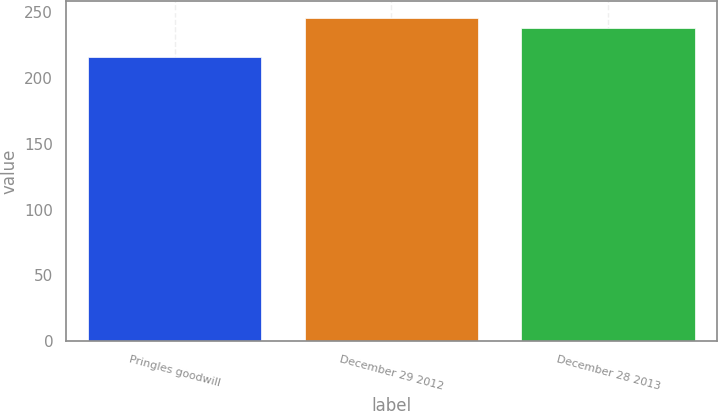<chart> <loc_0><loc_0><loc_500><loc_500><bar_chart><fcel>Pringles goodwill<fcel>December 29 2012<fcel>December 28 2013<nl><fcel>216<fcel>246<fcel>238<nl></chart> 